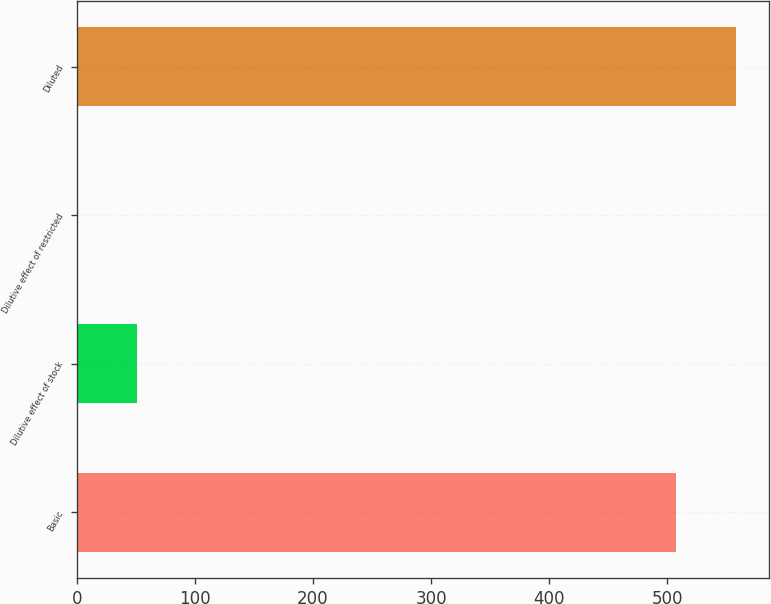Convert chart to OTSL. <chart><loc_0><loc_0><loc_500><loc_500><bar_chart><fcel>Basic<fcel>Dilutive effect of stock<fcel>Dilutive effect of restricted<fcel>Diluted<nl><fcel>507<fcel>51.22<fcel>0.4<fcel>557.82<nl></chart> 